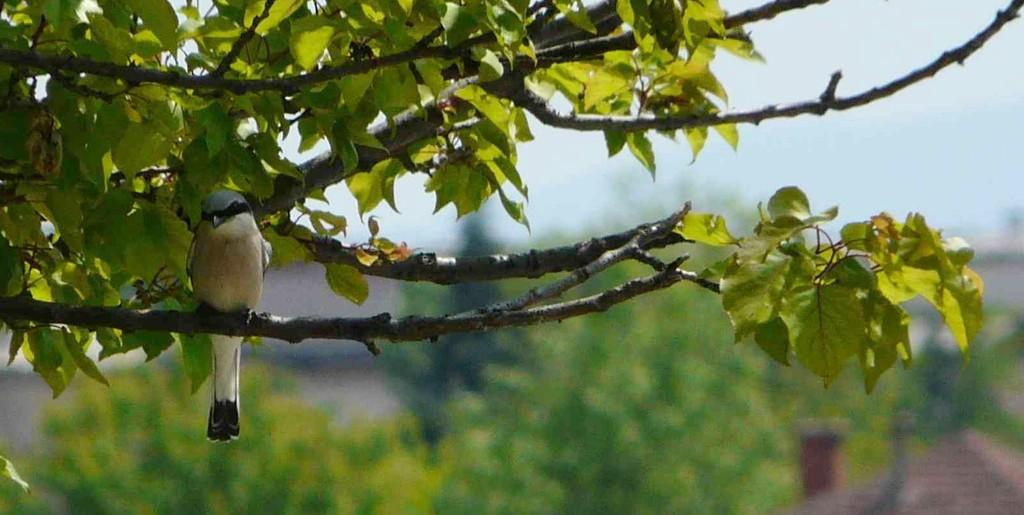What type of animal can be seen in the image? There is a bird in the image. Where is the bird located? The bird is on a tree. Can you describe the background of the image? The background of the image is blurred. How many brothers does the bird have in the image? There is no information about the bird's family in the image, so it is impossible to determine the number of brothers the bird has. 